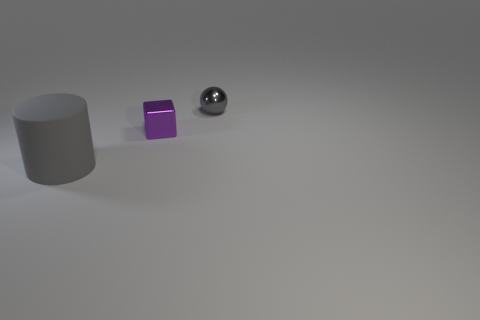Add 2 matte objects. How many objects exist? 5 Subtract all cubes. How many objects are left? 2 Subtract all cyan cubes. Subtract all gray balls. How many cubes are left? 1 Add 1 yellow blocks. How many yellow blocks exist? 1 Subtract 1 purple blocks. How many objects are left? 2 Subtract all small metallic objects. Subtract all blue rubber cubes. How many objects are left? 1 Add 1 rubber cylinders. How many rubber cylinders are left? 2 